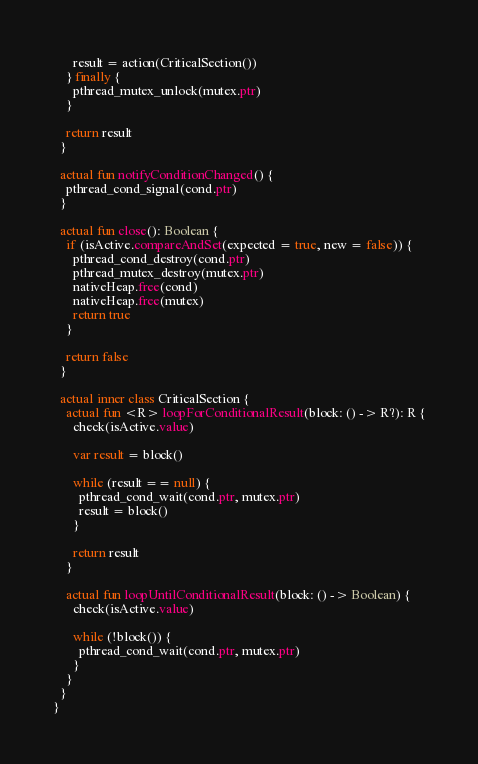Convert code to text. <code><loc_0><loc_0><loc_500><loc_500><_Kotlin_>      result = action(CriticalSection())
    } finally {
      pthread_mutex_unlock(mutex.ptr)
    }

    return result
  }

  actual fun notifyConditionChanged() {
    pthread_cond_signal(cond.ptr)
  }

  actual fun close(): Boolean {
    if (isActive.compareAndSet(expected = true, new = false)) {
      pthread_cond_destroy(cond.ptr)
      pthread_mutex_destroy(mutex.ptr)
      nativeHeap.free(cond)
      nativeHeap.free(mutex)
      return true
    }

    return false
  }

  actual inner class CriticalSection {
    actual fun <R> loopForConditionalResult(block: () -> R?): R {
      check(isActive.value)

      var result = block()

      while (result == null) {
        pthread_cond_wait(cond.ptr, mutex.ptr)
        result = block()
      }

      return result
    }

    actual fun loopUntilConditionalResult(block: () -> Boolean) {
      check(isActive.value)

      while (!block()) {
        pthread_cond_wait(cond.ptr, mutex.ptr)
      }
    }
  }
}
</code> 